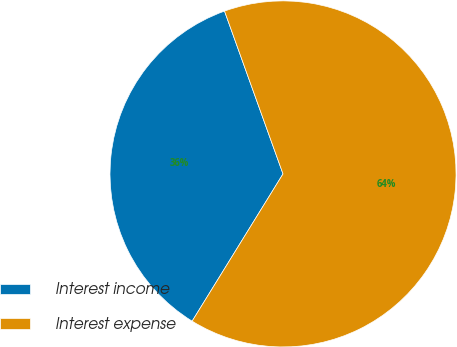Convert chart. <chart><loc_0><loc_0><loc_500><loc_500><pie_chart><fcel>Interest income<fcel>Interest expense<nl><fcel>35.71%<fcel>64.29%<nl></chart> 